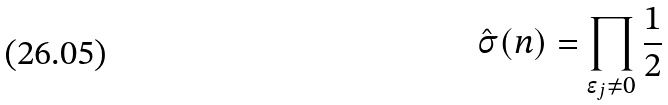<formula> <loc_0><loc_0><loc_500><loc_500>\hat { \sigma } ( n ) = \prod _ { \epsilon _ { j } \neq 0 } \frac { 1 } { 2 }</formula> 